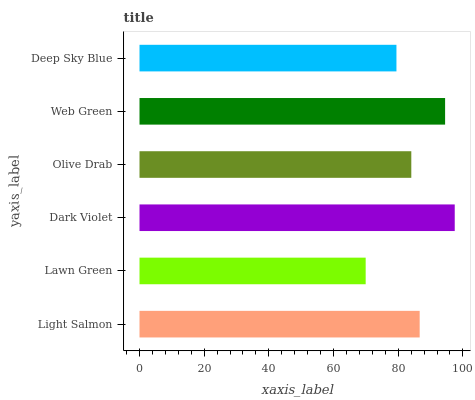Is Lawn Green the minimum?
Answer yes or no. Yes. Is Dark Violet the maximum?
Answer yes or no. Yes. Is Dark Violet the minimum?
Answer yes or no. No. Is Lawn Green the maximum?
Answer yes or no. No. Is Dark Violet greater than Lawn Green?
Answer yes or no. Yes. Is Lawn Green less than Dark Violet?
Answer yes or no. Yes. Is Lawn Green greater than Dark Violet?
Answer yes or no. No. Is Dark Violet less than Lawn Green?
Answer yes or no. No. Is Light Salmon the high median?
Answer yes or no. Yes. Is Olive Drab the low median?
Answer yes or no. Yes. Is Dark Violet the high median?
Answer yes or no. No. Is Lawn Green the low median?
Answer yes or no. No. 